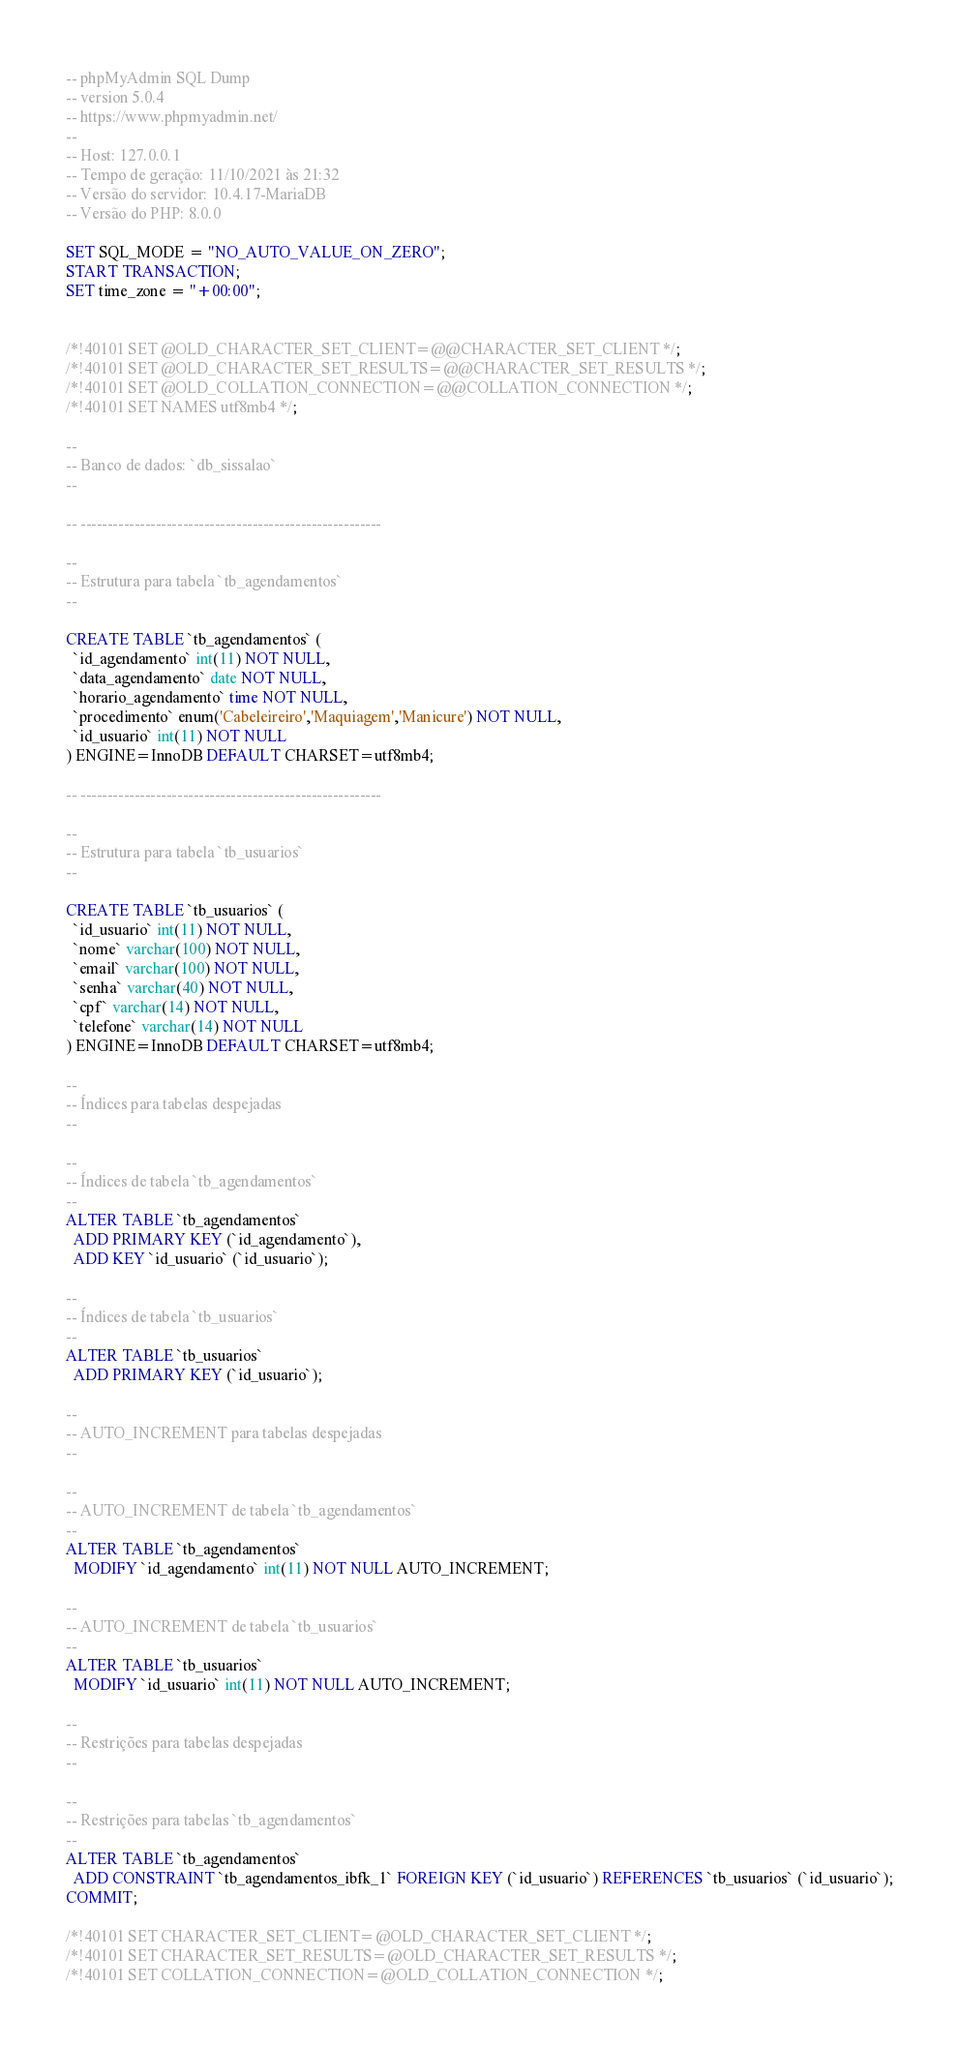Convert code to text. <code><loc_0><loc_0><loc_500><loc_500><_SQL_>-- phpMyAdmin SQL Dump
-- version 5.0.4
-- https://www.phpmyadmin.net/
--
-- Host: 127.0.0.1
-- Tempo de geração: 11/10/2021 às 21:32
-- Versão do servidor: 10.4.17-MariaDB
-- Versão do PHP: 8.0.0

SET SQL_MODE = "NO_AUTO_VALUE_ON_ZERO";
START TRANSACTION;
SET time_zone = "+00:00";


/*!40101 SET @OLD_CHARACTER_SET_CLIENT=@@CHARACTER_SET_CLIENT */;
/*!40101 SET @OLD_CHARACTER_SET_RESULTS=@@CHARACTER_SET_RESULTS */;
/*!40101 SET @OLD_COLLATION_CONNECTION=@@COLLATION_CONNECTION */;
/*!40101 SET NAMES utf8mb4 */;

--
-- Banco de dados: `db_sissalao`
--

-- --------------------------------------------------------

--
-- Estrutura para tabela `tb_agendamentos`
--

CREATE TABLE `tb_agendamentos` (
  `id_agendamento` int(11) NOT NULL,
  `data_agendamento` date NOT NULL,
  `horario_agendamento` time NOT NULL,
  `procedimento` enum('Cabeleireiro','Maquiagem','Manicure') NOT NULL,
  `id_usuario` int(11) NOT NULL
) ENGINE=InnoDB DEFAULT CHARSET=utf8mb4;

-- --------------------------------------------------------

--
-- Estrutura para tabela `tb_usuarios`
--

CREATE TABLE `tb_usuarios` (
  `id_usuario` int(11) NOT NULL,
  `nome` varchar(100) NOT NULL,
  `email` varchar(100) NOT NULL,
  `senha` varchar(40) NOT NULL,
  `cpf` varchar(14) NOT NULL,
  `telefone` varchar(14) NOT NULL
) ENGINE=InnoDB DEFAULT CHARSET=utf8mb4;

--
-- Índices para tabelas despejadas
--

--
-- Índices de tabela `tb_agendamentos`
--
ALTER TABLE `tb_agendamentos`
  ADD PRIMARY KEY (`id_agendamento`),
  ADD KEY `id_usuario` (`id_usuario`);

--
-- Índices de tabela `tb_usuarios`
--
ALTER TABLE `tb_usuarios`
  ADD PRIMARY KEY (`id_usuario`);

--
-- AUTO_INCREMENT para tabelas despejadas
--

--
-- AUTO_INCREMENT de tabela `tb_agendamentos`
--
ALTER TABLE `tb_agendamentos`
  MODIFY `id_agendamento` int(11) NOT NULL AUTO_INCREMENT;

--
-- AUTO_INCREMENT de tabela `tb_usuarios`
--
ALTER TABLE `tb_usuarios`
  MODIFY `id_usuario` int(11) NOT NULL AUTO_INCREMENT;

--
-- Restrições para tabelas despejadas
--

--
-- Restrições para tabelas `tb_agendamentos`
--
ALTER TABLE `tb_agendamentos`
  ADD CONSTRAINT `tb_agendamentos_ibfk_1` FOREIGN KEY (`id_usuario`) REFERENCES `tb_usuarios` (`id_usuario`);
COMMIT;

/*!40101 SET CHARACTER_SET_CLIENT=@OLD_CHARACTER_SET_CLIENT */;
/*!40101 SET CHARACTER_SET_RESULTS=@OLD_CHARACTER_SET_RESULTS */;
/*!40101 SET COLLATION_CONNECTION=@OLD_COLLATION_CONNECTION */;
</code> 